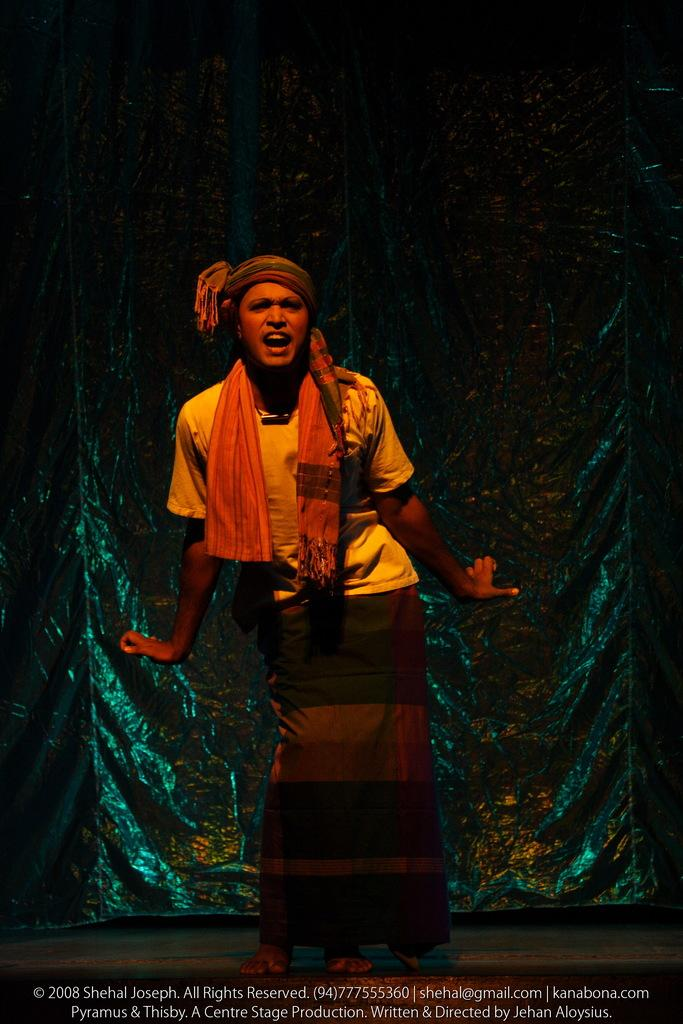What is the main subject of the image? There is a person standing in the image. What can be seen in the background of the image? There is a curtain visible in the background of the image. What is the surface on which the person is standing? There is a floor in the image. What else is present in the image besides the person and the curtain? There is text present in the image. How many rail tickets does the person have in the image? There is no rail ticket present in the image. What type of hearing aid is the person using in the image? There is no hearing aid visible in the image. 